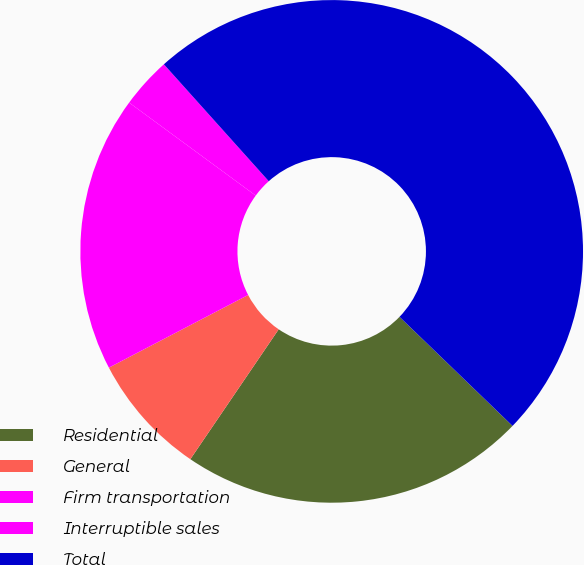Convert chart to OTSL. <chart><loc_0><loc_0><loc_500><loc_500><pie_chart><fcel>Residential<fcel>General<fcel>Firm transportation<fcel>Interruptible sales<fcel>Total<nl><fcel>22.29%<fcel>7.84%<fcel>17.74%<fcel>3.28%<fcel>48.86%<nl></chart> 